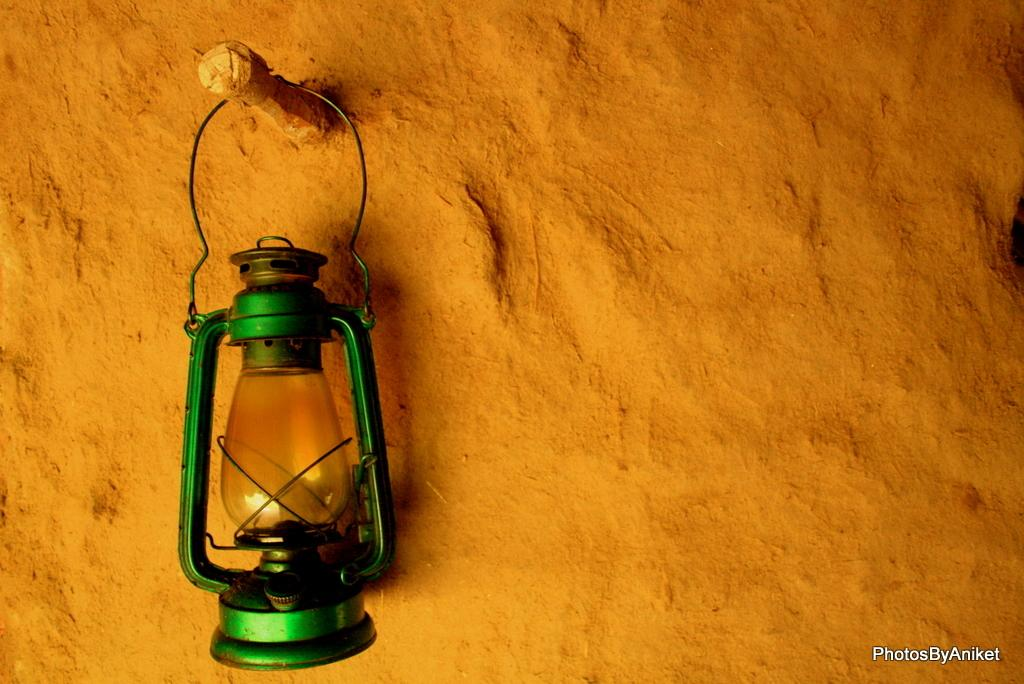What type of lamp is visible in the image? There is a hurricane lamp in the image. How is the hurricane lamp positioned in the image? The hurricane lamp is hanged on a pole. What scientific experiment is being conducted with the hurricane lamp in the image? There is no scientific experiment visible in the image; it only shows a hurricane lamp hanging on a pole. 